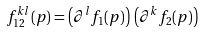<formula> <loc_0><loc_0><loc_500><loc_500>f _ { 1 2 } ^ { k l } ( p ) = \left ( \partial ^ { l } f _ { 1 } ( p ) \right ) \, \left ( \partial ^ { k } f _ { 2 } ( p ) \right ) \,</formula> 